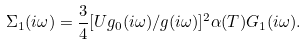Convert formula to latex. <formula><loc_0><loc_0><loc_500><loc_500>\Sigma _ { 1 } ( i \omega ) = \frac { 3 } { 4 } [ U g _ { 0 } ( i \omega ) / g ( i \omega ) ] ^ { 2 } \alpha ( T ) G _ { 1 } ( i \omega ) .</formula> 